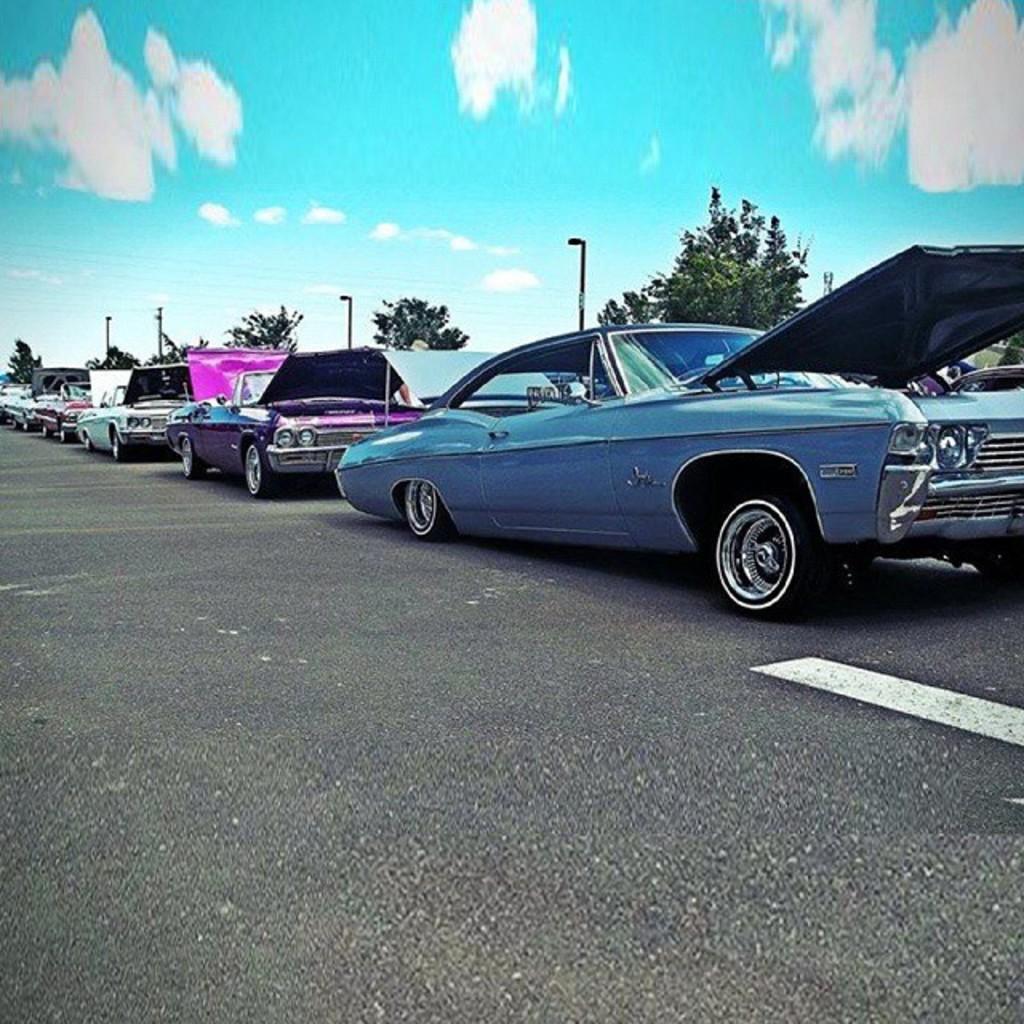Please provide a concise description of this image. In this image we can see some vehicles parked on the road, four poles with lights, one object looks like a pole, one object on the right side of the image, some trees on the ground and at the top there is the cloudy sky. 